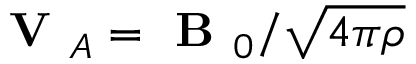<formula> <loc_0><loc_0><loc_500><loc_500>V _ { A } = B _ { 0 } / \sqrt { 4 \pi \rho }</formula> 